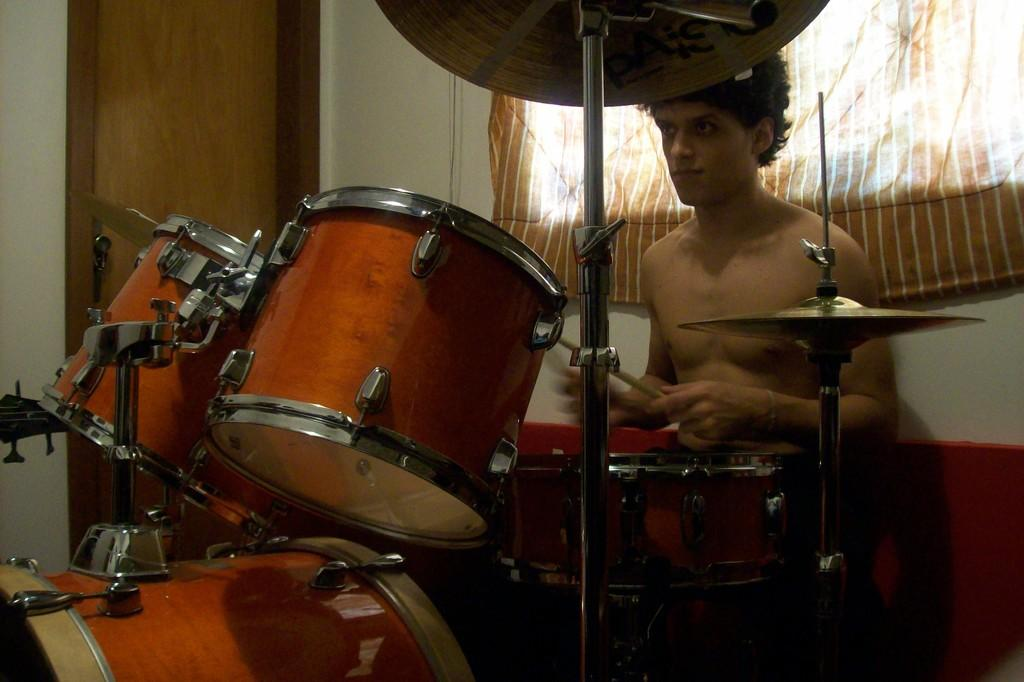What is the main subject of the image? There is a man in the image. What is the man doing in the image? The man is playing a drum. Can you describe the man's attire in the image? The man is not wearing a shirt in the image. What architectural features can be seen in the image? There is a window with a curtain and a door on the left side of the image. Where is the window located in relation to the man? The window is behind the man in the image. Can you describe the wall on which the door is located? The door is on a wall on the left side of the image. What type of wire is being used to hold the tomatoes in the image? There are no tomatoes or wires present in the image. What kind of system is being used to organize the tomatoes in the image? There are no tomatoes or systems present in the image. 